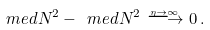Convert formula to latex. <formula><loc_0><loc_0><loc_500><loc_500>\ m e d { N ^ { 2 } } - \ m e d { N } ^ { 2 } \stackrel { _ { \eta \rightarrow \infty } } { \longrightarrow } 0 \, .</formula> 